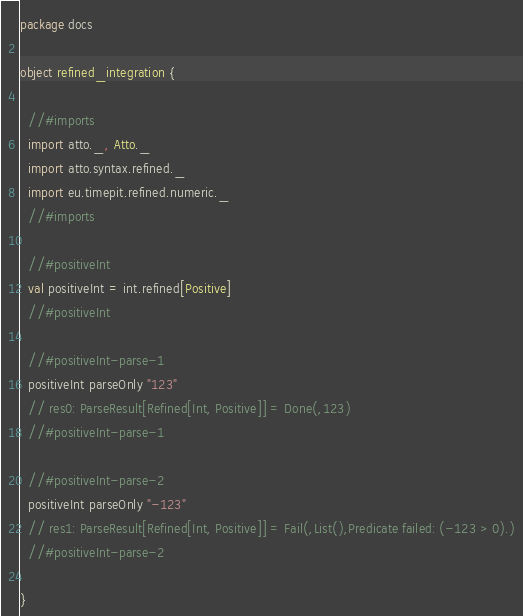<code> <loc_0><loc_0><loc_500><loc_500><_Scala_>package docs

object refined_integration {

  //#imports
  import atto._, Atto._
  import atto.syntax.refined._
  import eu.timepit.refined.numeric._
  //#imports

  //#positiveInt
  val positiveInt = int.refined[Positive]
  //#positiveInt

  //#positiveInt-parse-1
  positiveInt parseOnly "123"
  // res0: ParseResult[Refined[Int, Positive]] = Done(,123)
  //#positiveInt-parse-1

  //#positiveInt-parse-2
  positiveInt parseOnly "-123"
  // res1: ParseResult[Refined[Int, Positive]] = Fail(,List(),Predicate failed: (-123 > 0).)
  //#positiveInt-parse-2

}</code> 